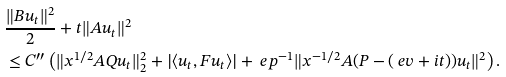<formula> <loc_0><loc_0><loc_500><loc_500>& \frac { \| B u _ { t } \| ^ { 2 } } { 2 } + t \| A u _ { t } \| ^ { 2 } \\ & \leq C ^ { \prime \prime } \left ( \| x ^ { 1 / 2 } A Q u _ { t } \| _ { 2 } ^ { 2 } + | \langle u _ { t } , F u _ { t } \rangle | + \ e p ^ { - 1 } \| x ^ { - 1 / 2 } A ( P - ( \ e v + i t ) ) u _ { t } \| ^ { 2 } \right ) .</formula> 